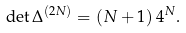<formula> <loc_0><loc_0><loc_500><loc_500>\det \Delta ^ { ( 2 N ) } = \left ( N + 1 \right ) 4 ^ { N } .</formula> 